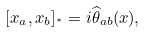<formula> <loc_0><loc_0><loc_500><loc_500>[ x _ { a } , x _ { b } ] _ { ^ { * } } = i \widehat { \theta } _ { a b } ( x ) ,</formula> 